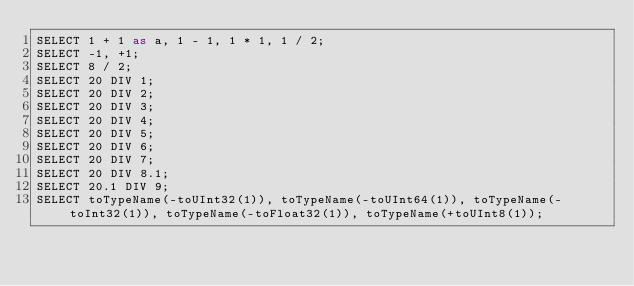<code> <loc_0><loc_0><loc_500><loc_500><_SQL_>SELECT 1 + 1 as a, 1 - 1, 1 * 1, 1 / 2;
SELECT -1, +1;
SELECT 8 / 2;
SELECT 20 DIV 1;
SELECT 20 DIV 2;
SELECT 20 DIV 3;
SELECT 20 DIV 4;
SELECT 20 DIV 5;
SELECT 20 DIV 6;
SELECT 20 DIV 7;
SELECT 20 DIV 8.1;
SELECT 20.1 DIV 9;
SELECT toTypeName(-toUInt32(1)), toTypeName(-toUInt64(1)), toTypeName(-toInt32(1)), toTypeName(-toFloat32(1)), toTypeName(+toUInt8(1));
</code> 